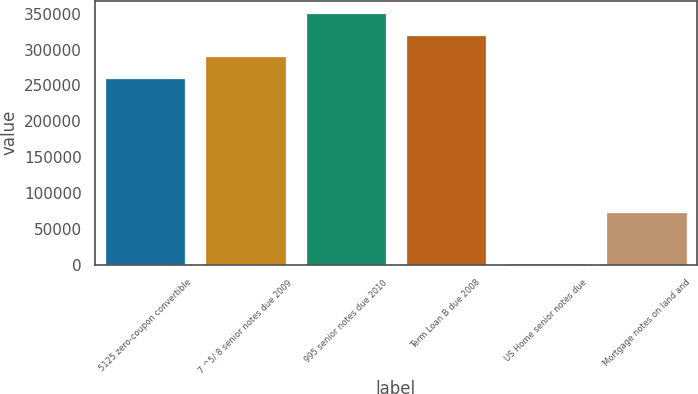Convert chart to OTSL. <chart><loc_0><loc_0><loc_500><loc_500><bar_chart><fcel>5125 zero-coupon convertible<fcel>7 ^5/ 8 senior notes due 2009<fcel>995 senior notes due 2010<fcel>Term Loan B due 2008<fcel>US Home senior notes due<fcel>Mortgage notes on land and<nl><fcel>261012<fcel>290975<fcel>350900<fcel>320938<fcel>2367<fcel>72990<nl></chart> 